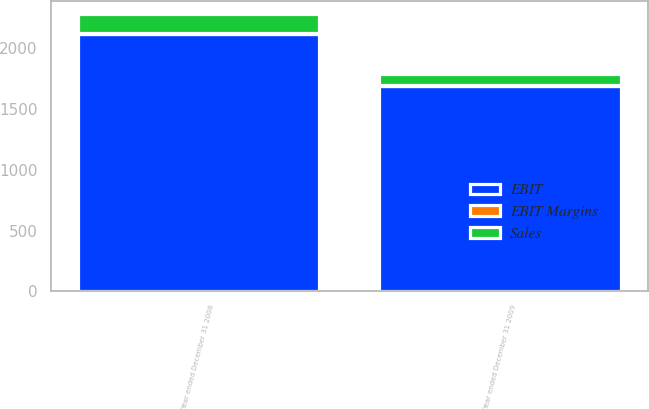Convert chart to OTSL. <chart><loc_0><loc_0><loc_500><loc_500><stacked_bar_chart><ecel><fcel>Year ended December 31 2009<fcel>Year ended December 31 2008<nl><fcel>EBIT<fcel>1693<fcel>2120<nl><fcel>Sales<fcel>90<fcel>151<nl><fcel>EBIT Margins<fcel>5.3<fcel>7.1<nl></chart> 